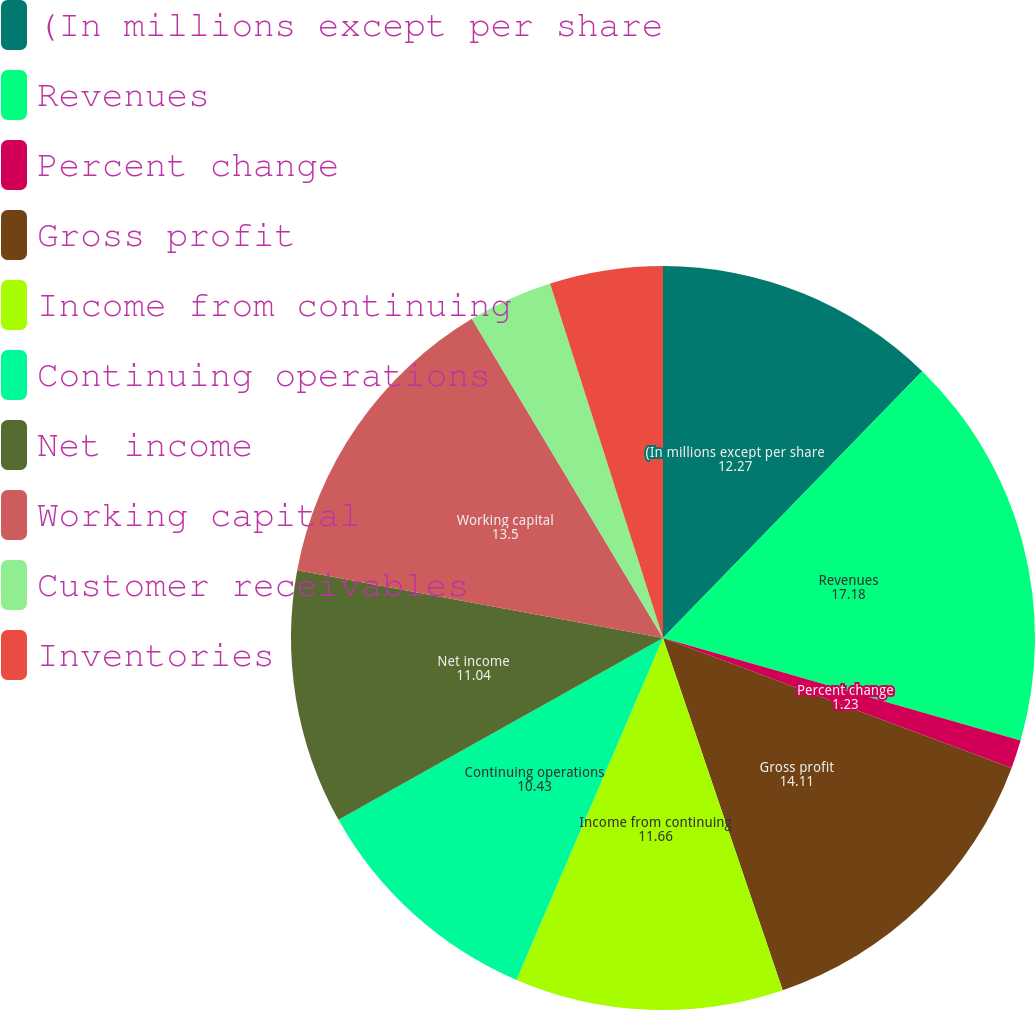Convert chart to OTSL. <chart><loc_0><loc_0><loc_500><loc_500><pie_chart><fcel>(In millions except per share<fcel>Revenues<fcel>Percent change<fcel>Gross profit<fcel>Income from continuing<fcel>Continuing operations<fcel>Net income<fcel>Working capital<fcel>Customer receivables<fcel>Inventories<nl><fcel>12.27%<fcel>17.18%<fcel>1.23%<fcel>14.11%<fcel>11.66%<fcel>10.43%<fcel>11.04%<fcel>13.5%<fcel>3.68%<fcel>4.91%<nl></chart> 